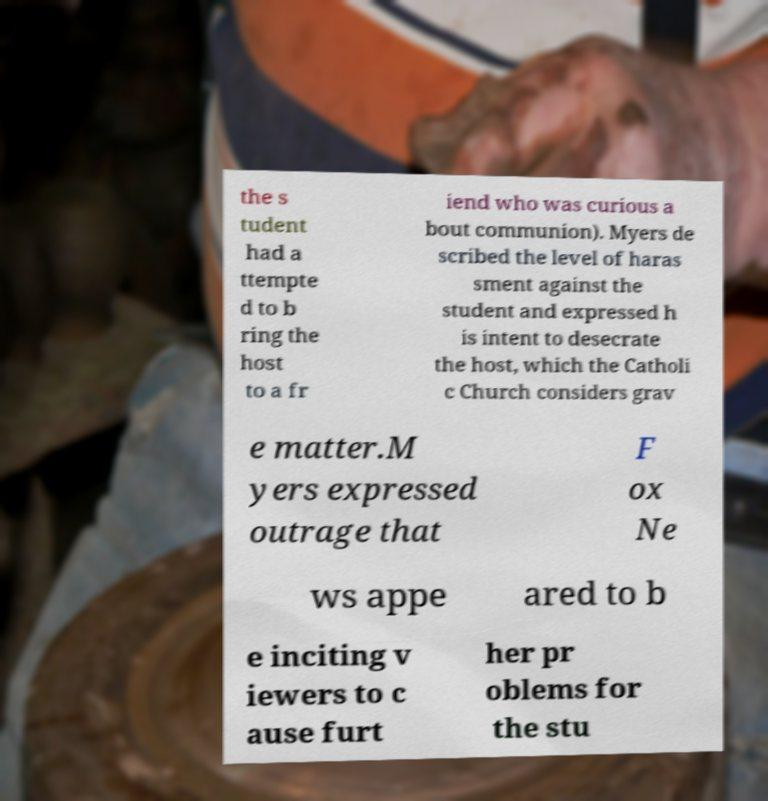I need the written content from this picture converted into text. Can you do that? the s tudent had a ttempte d to b ring the host to a fr iend who was curious a bout communion). Myers de scribed the level of haras sment against the student and expressed h is intent to desecrate the host, which the Catholi c Church considers grav e matter.M yers expressed outrage that F ox Ne ws appe ared to b e inciting v iewers to c ause furt her pr oblems for the stu 